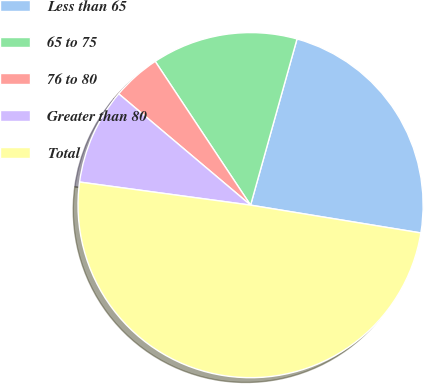Convert chart. <chart><loc_0><loc_0><loc_500><loc_500><pie_chart><fcel>Less than 65<fcel>65 to 75<fcel>76 to 80<fcel>Greater than 80<fcel>Total<nl><fcel>23.24%<fcel>13.66%<fcel>4.52%<fcel>9.02%<fcel>49.56%<nl></chart> 